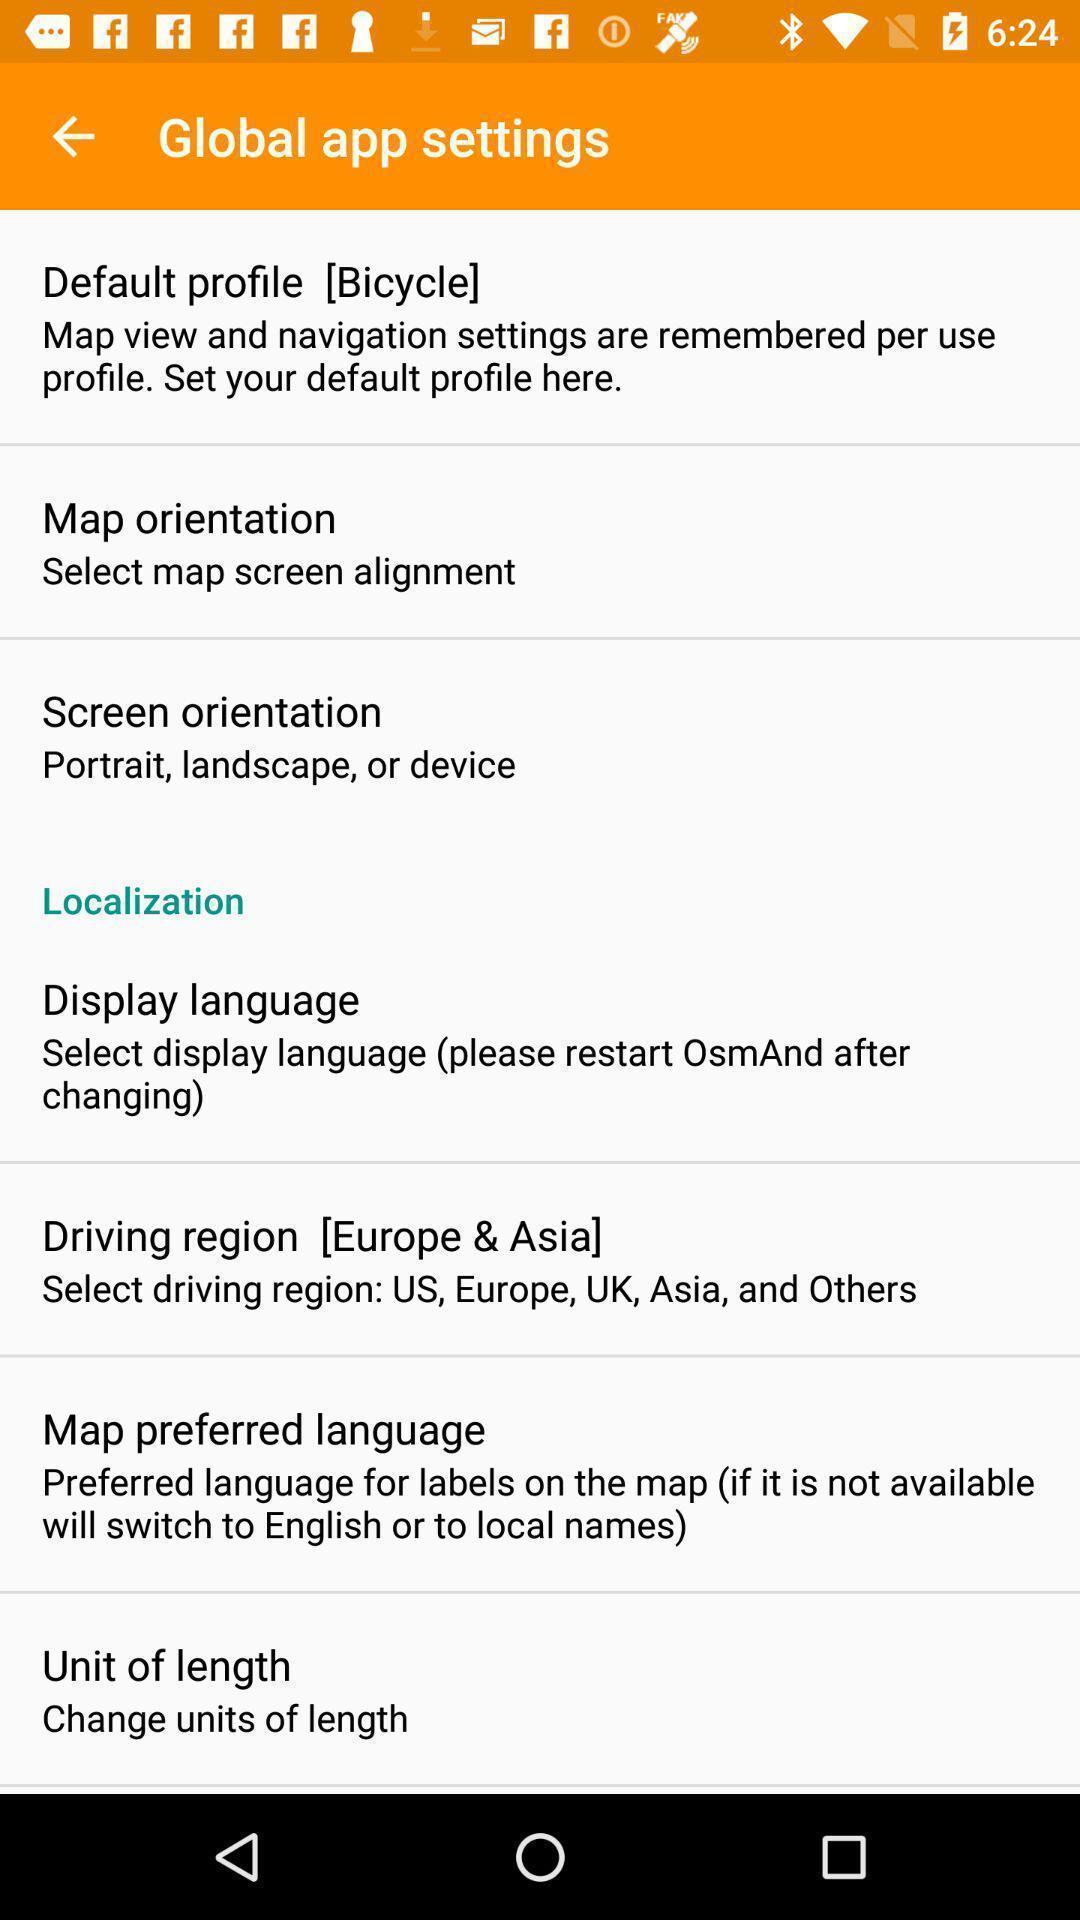Summarize the main components in this picture. Page displaying settings information about an offline navigation application. 